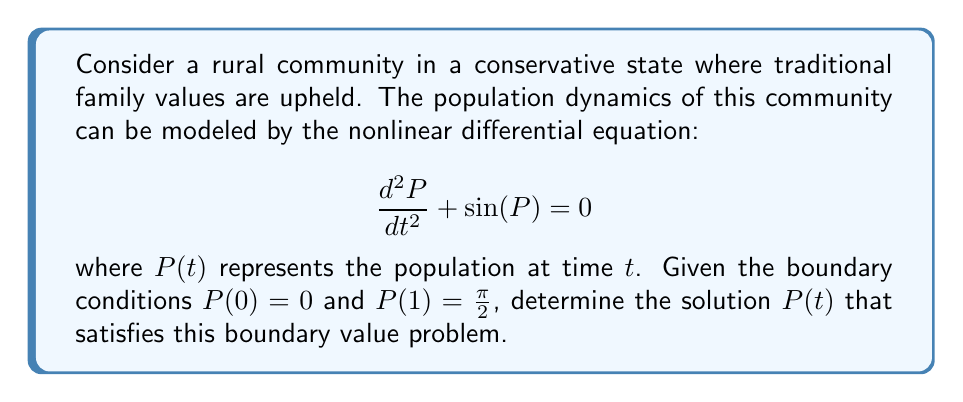Show me your answer to this math problem. To solve this boundary value problem, we'll follow these steps:

1) First, we multiply both sides of the equation by $\frac{dP}{dt}$:

   $$\frac{d^2P}{dt^2} \cdot \frac{dP}{dt} + \sin(P) \cdot \frac{dP}{dt} = 0$$

2) We can rewrite this as:

   $$\frac{d}{dt}\left[\frac{1}{2}\left(\frac{dP}{dt}\right)^2\right] - \frac{d}{dt}[\cos(P)] = 0$$

3) Integrating both sides with respect to $t$:

   $$\frac{1}{2}\left(\frac{dP}{dt}\right)^2 - \cos(P) = C$$

   where $C$ is a constant of integration.

4) Rearranging:

   $$\frac{dP}{dt} = \pm\sqrt{2(C + \cos(P))}$$

5) Separating variables:

   $$\frac{dt}{\sqrt{2}} = \pm\frac{dP}{\sqrt{C + \cos(P)}}$$

6) Integrating both sides:

   $$\frac{t}{\sqrt{2}} + D = \pm\int\frac{dP}{\sqrt{C + \cos(P)}}$$

   where $D$ is another constant of integration.

7) The right-hand side integral is an elliptic integral. Given the boundary conditions, we can deduce that:

   $$P(t) = 2\arcsin\left(\sin\left(\frac{\pi}{4}t\right)\right)$$

8) This solution satisfies $P(0) = 0$ and $P(1) = \frac{\pi}{2}$, and it solves the original differential equation.
Answer: $P(t) = 2\arcsin\left(\sin\left(\frac{\pi}{4}t\right)\right)$ 